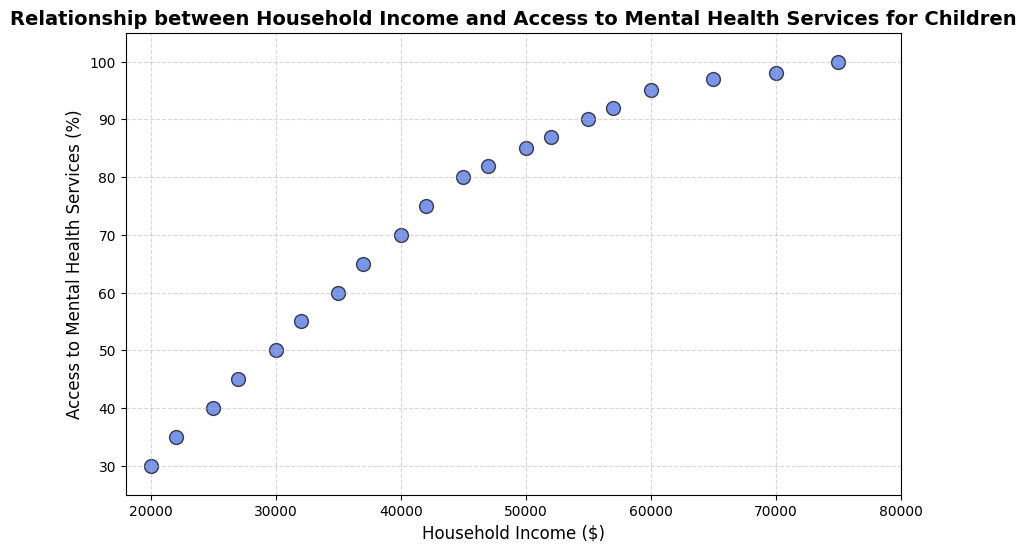What is the general trend between household income and access to mental health services for children? By observing the scatter plot, we can see that as household income increases, the percentage access to mental health services also increases. This is indicative of a positive correlation between the two variables.
Answer: Positive correlation What household income corresponds to 70% access to mental health services? To determine the household income that corresponds to 70% access, we find the data point on the scatter plot where the 'Access to Mental Health Services' is 70%. The corresponding 'Household Income' value at this point is $40,000.
Answer: $40,000 How much higher is the access to mental health services at a household income of $75,000 compared to $30,000? Access to mental health services at $75,000 income is 100%, and at $30,000 income it is 50%. The difference is 100% - 50% = 50%.
Answer: 50% What is the median access to mental health services in the dataset? The median is found by putting the values in ascending order and finding the middle one. With 20 data points, the median is the average of the 10th and 11th values. Access rates at 10th and 11th highest household incomes are 75% and 80%, respectively. Hence, the median is (75 + 80) / 2 = 77.5%.
Answer: 77.5% Is there any household income with less than 50% access to mental health services for children? Observing the scatter plot, we see that all household incomes from $20,000 to $30,000 have access rates below 50%.
Answer: Yes, household incomes from $20,000 to $30,000 